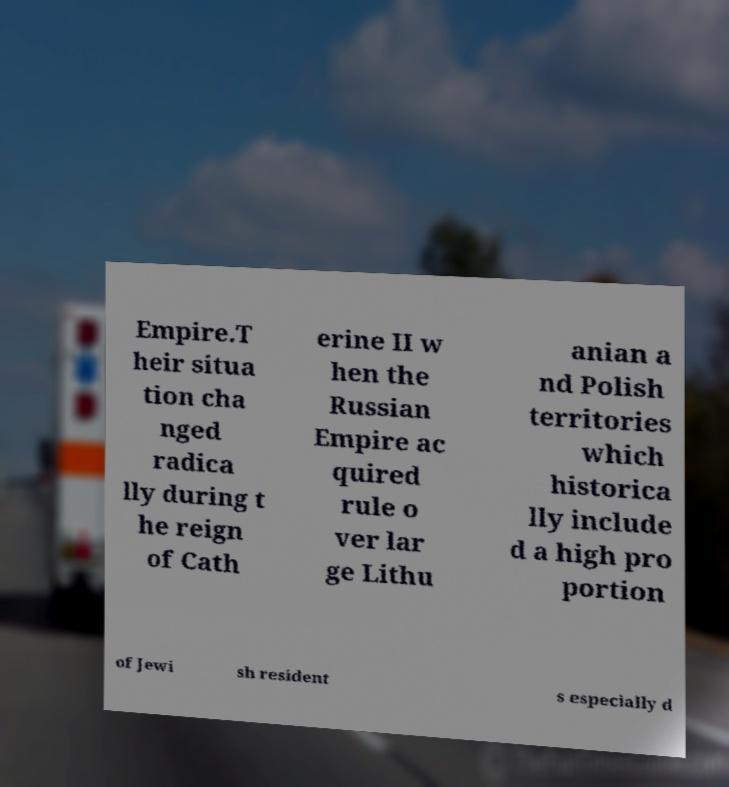Could you extract and type out the text from this image? Empire.T heir situa tion cha nged radica lly during t he reign of Cath erine II w hen the Russian Empire ac quired rule o ver lar ge Lithu anian a nd Polish territories which historica lly include d a high pro portion of Jewi sh resident s especially d 